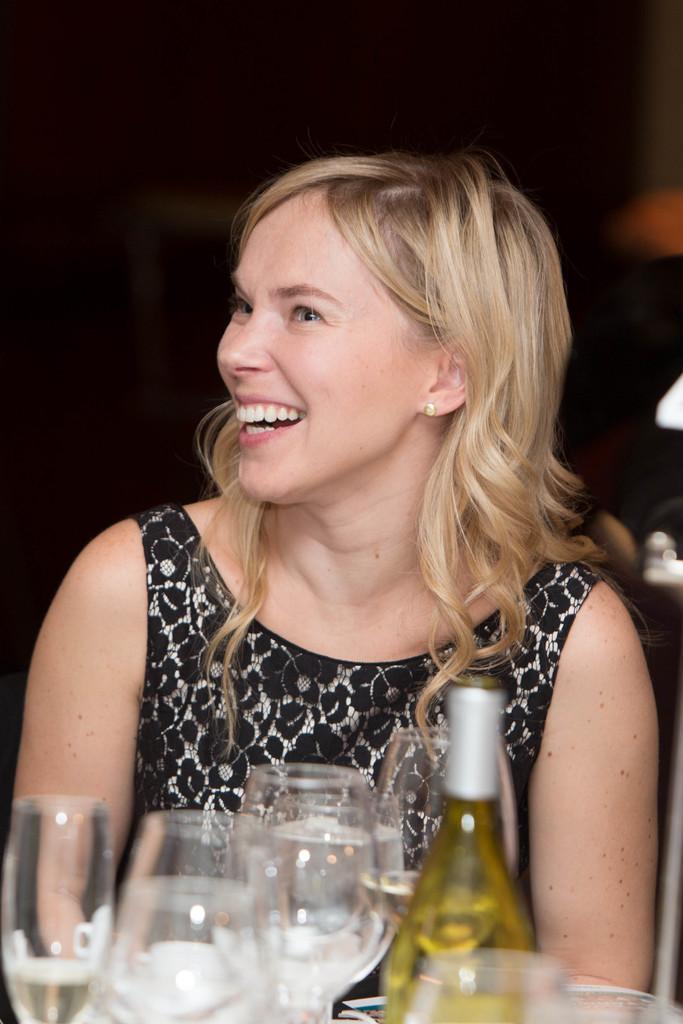Please provide a concise description of this image. This person sitting and smiling and wear black color dress.. We can see glasses and bottle. 